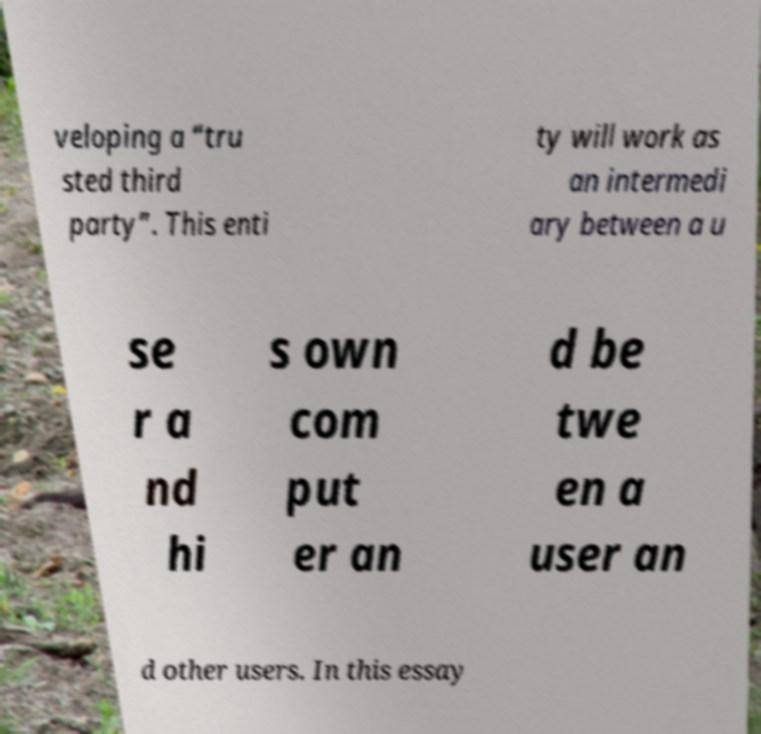Please read and relay the text visible in this image. What does it say? veloping a “tru sted third party”. This enti ty will work as an intermedi ary between a u se r a nd hi s own com put er an d be twe en a user an d other users. In this essay 